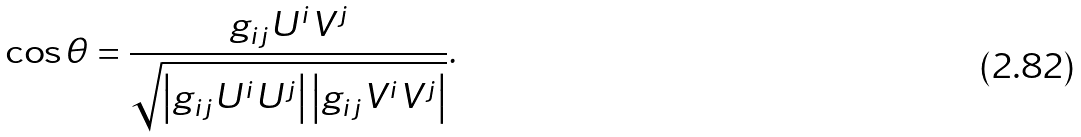Convert formula to latex. <formula><loc_0><loc_0><loc_500><loc_500>\cos \theta = { \frac { g _ { i j } U ^ { i } V ^ { j } } { \sqrt { \left | g _ { i j } U ^ { i } U ^ { j } \right | \left | g _ { i j } V ^ { i } V ^ { j } \right | } } } .</formula> 